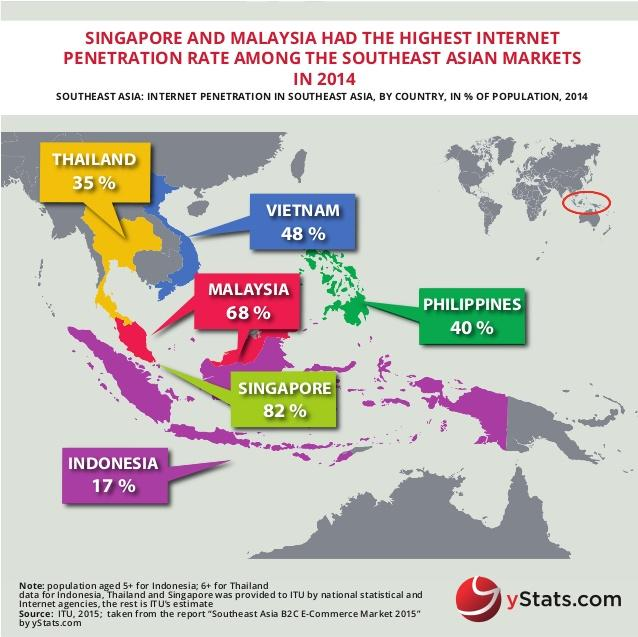Specify some key components in this picture. Singapore and Malaysia are the countries with the highest internet penetration. The country of Vietnam is depicted in blue in the image. According to the provided data, Thailand, Vietnam, and the Philippines have internet penetration rates that fall within the ranges of 30% and 50%. Specifically, Thailand has an internet penetration rate of 45.8%, Vietnam has a rate of 44.7%, and the Philippines has a rate of 41.5%. This means that these countries have a moderate level of internet access, with a significant portion of their population online. The region circled in red is South East Asia. 